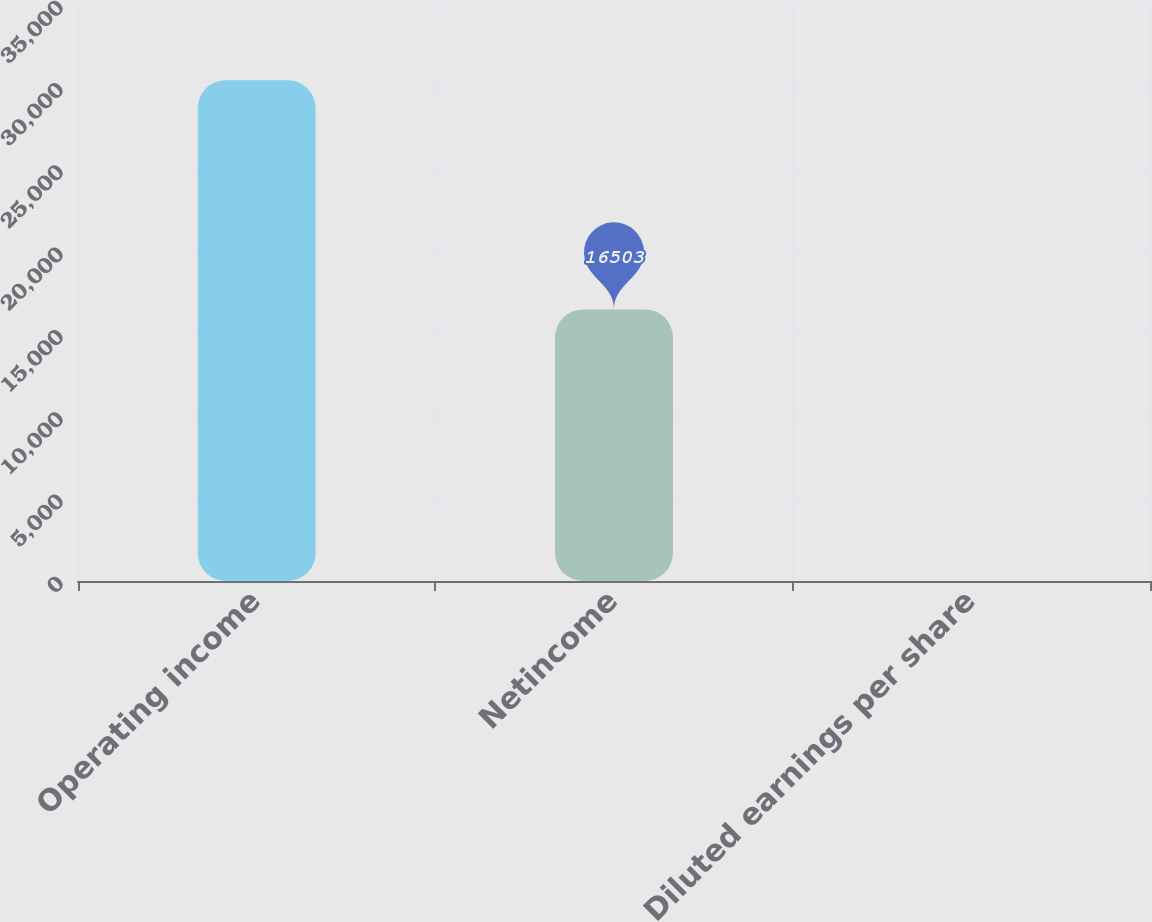Convert chart. <chart><loc_0><loc_0><loc_500><loc_500><bar_chart><fcel>Operating income<fcel>Netincome<fcel>Diluted earnings per share<nl><fcel>30432<fcel>16503<fcel>0.42<nl></chart> 